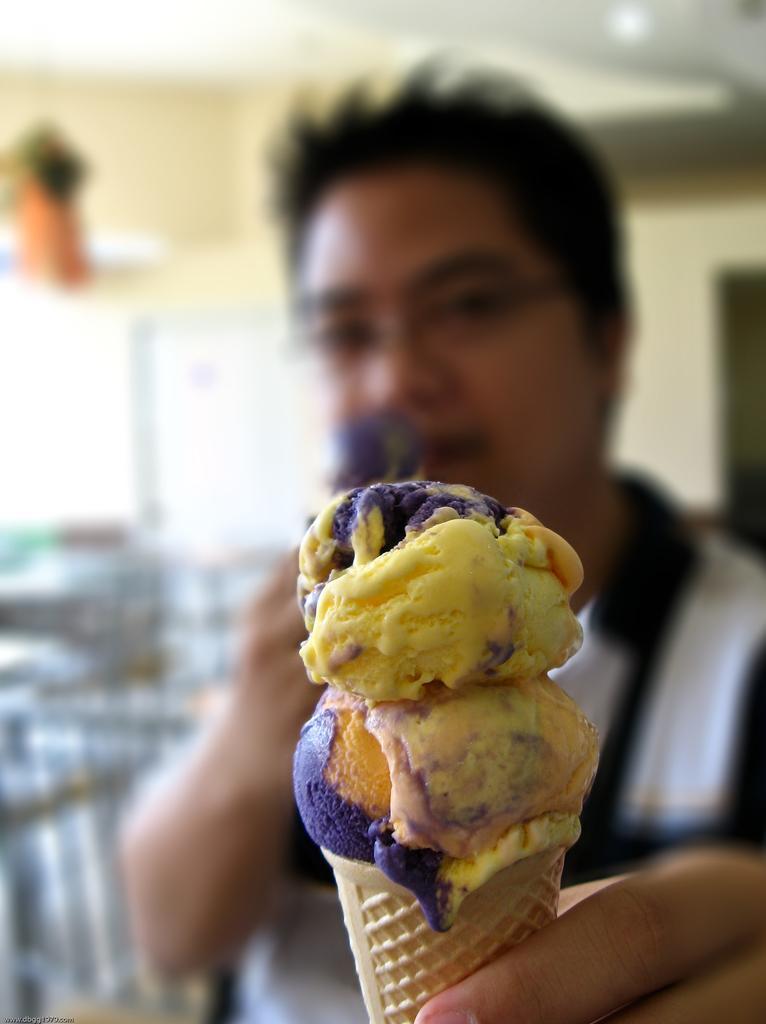How would you summarize this image in a sentence or two? In this image there is a man who is holding the ice cream with his hand. In the background there are tables and chairs around it. At the top there is ceiling with the lights. 